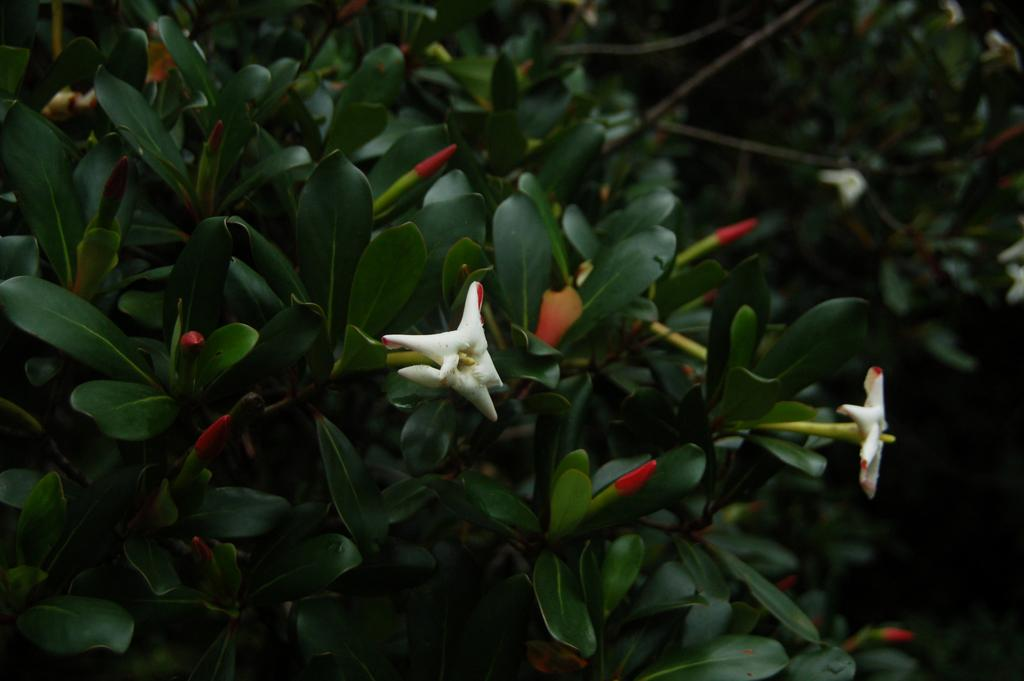What type of living organisms can be seen in the image? Plants and flowers are visible in the image. Can you describe the stage of growth for some of the plants in the image? Yes, there are buds in the image, which suggests that some of the plants are in the early stages of growth. Is there a swing in the image? No, there is no swing present in the image. Can the plants in the image help with any tasks or chores? The plants in the image are not capable of performing tasks or chores, as they are living organisms and not sentient beings. 